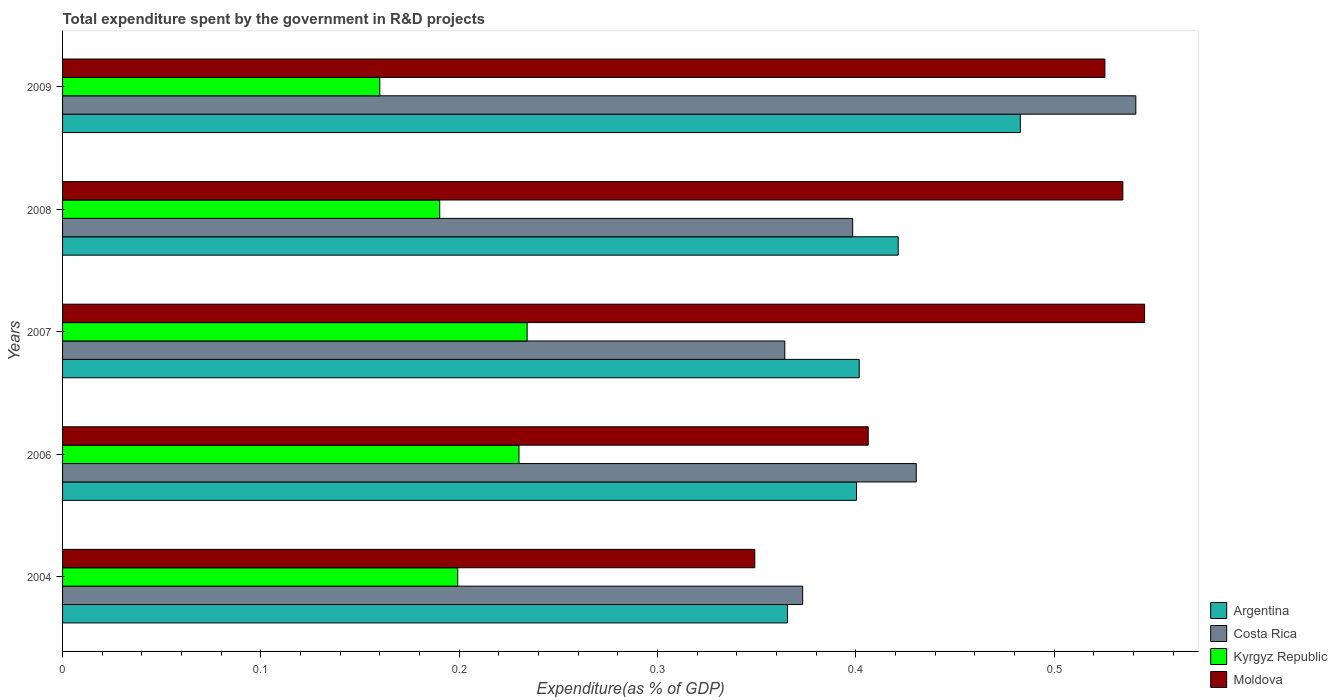How many different coloured bars are there?
Offer a very short reply. 4. How many groups of bars are there?
Ensure brevity in your answer.  5. Are the number of bars per tick equal to the number of legend labels?
Your answer should be very brief. Yes. How many bars are there on the 1st tick from the top?
Offer a terse response. 4. What is the label of the 3rd group of bars from the top?
Your answer should be compact. 2007. What is the total expenditure spent by the government in R&D projects in Costa Rica in 2009?
Make the answer very short. 0.54. Across all years, what is the maximum total expenditure spent by the government in R&D projects in Moldova?
Offer a terse response. 0.55. Across all years, what is the minimum total expenditure spent by the government in R&D projects in Kyrgyz Republic?
Give a very brief answer. 0.16. What is the total total expenditure spent by the government in R&D projects in Moldova in the graph?
Provide a short and direct response. 2.36. What is the difference between the total expenditure spent by the government in R&D projects in Kyrgyz Republic in 2006 and that in 2008?
Make the answer very short. 0.04. What is the difference between the total expenditure spent by the government in R&D projects in Costa Rica in 2004 and the total expenditure spent by the government in R&D projects in Kyrgyz Republic in 2007?
Your answer should be compact. 0.14. What is the average total expenditure spent by the government in R&D projects in Costa Rica per year?
Your answer should be very brief. 0.42. In the year 2009, what is the difference between the total expenditure spent by the government in R&D projects in Moldova and total expenditure spent by the government in R&D projects in Costa Rica?
Offer a very short reply. -0.02. What is the ratio of the total expenditure spent by the government in R&D projects in Argentina in 2007 to that in 2009?
Provide a short and direct response. 0.83. Is the total expenditure spent by the government in R&D projects in Costa Rica in 2006 less than that in 2007?
Offer a terse response. No. What is the difference between the highest and the second highest total expenditure spent by the government in R&D projects in Kyrgyz Republic?
Provide a short and direct response. 0. What is the difference between the highest and the lowest total expenditure spent by the government in R&D projects in Costa Rica?
Give a very brief answer. 0.18. In how many years, is the total expenditure spent by the government in R&D projects in Costa Rica greater than the average total expenditure spent by the government in R&D projects in Costa Rica taken over all years?
Your response must be concise. 2. Is the sum of the total expenditure spent by the government in R&D projects in Moldova in 2007 and 2008 greater than the maximum total expenditure spent by the government in R&D projects in Argentina across all years?
Provide a succinct answer. Yes. Is it the case that in every year, the sum of the total expenditure spent by the government in R&D projects in Moldova and total expenditure spent by the government in R&D projects in Argentina is greater than the sum of total expenditure spent by the government in R&D projects in Kyrgyz Republic and total expenditure spent by the government in R&D projects in Costa Rica?
Ensure brevity in your answer.  No. What does the 3rd bar from the top in 2004 represents?
Offer a terse response. Costa Rica. Is it the case that in every year, the sum of the total expenditure spent by the government in R&D projects in Moldova and total expenditure spent by the government in R&D projects in Argentina is greater than the total expenditure spent by the government in R&D projects in Kyrgyz Republic?
Ensure brevity in your answer.  Yes. How many bars are there?
Provide a succinct answer. 20. How many years are there in the graph?
Give a very brief answer. 5. What is the difference between two consecutive major ticks on the X-axis?
Provide a succinct answer. 0.1. Does the graph contain any zero values?
Keep it short and to the point. No. Does the graph contain grids?
Provide a succinct answer. No. Where does the legend appear in the graph?
Make the answer very short. Bottom right. How many legend labels are there?
Ensure brevity in your answer.  4. What is the title of the graph?
Provide a short and direct response. Total expenditure spent by the government in R&D projects. What is the label or title of the X-axis?
Give a very brief answer. Expenditure(as % of GDP). What is the Expenditure(as % of GDP) in Argentina in 2004?
Offer a very short reply. 0.37. What is the Expenditure(as % of GDP) in Costa Rica in 2004?
Your response must be concise. 0.37. What is the Expenditure(as % of GDP) in Kyrgyz Republic in 2004?
Give a very brief answer. 0.2. What is the Expenditure(as % of GDP) of Moldova in 2004?
Provide a succinct answer. 0.35. What is the Expenditure(as % of GDP) of Argentina in 2006?
Your response must be concise. 0.4. What is the Expenditure(as % of GDP) of Costa Rica in 2006?
Offer a very short reply. 0.43. What is the Expenditure(as % of GDP) in Kyrgyz Republic in 2006?
Your answer should be compact. 0.23. What is the Expenditure(as % of GDP) in Moldova in 2006?
Give a very brief answer. 0.41. What is the Expenditure(as % of GDP) of Argentina in 2007?
Offer a very short reply. 0.4. What is the Expenditure(as % of GDP) of Costa Rica in 2007?
Ensure brevity in your answer.  0.36. What is the Expenditure(as % of GDP) in Kyrgyz Republic in 2007?
Give a very brief answer. 0.23. What is the Expenditure(as % of GDP) in Moldova in 2007?
Give a very brief answer. 0.55. What is the Expenditure(as % of GDP) in Argentina in 2008?
Make the answer very short. 0.42. What is the Expenditure(as % of GDP) of Costa Rica in 2008?
Keep it short and to the point. 0.4. What is the Expenditure(as % of GDP) of Kyrgyz Republic in 2008?
Give a very brief answer. 0.19. What is the Expenditure(as % of GDP) of Moldova in 2008?
Make the answer very short. 0.53. What is the Expenditure(as % of GDP) in Argentina in 2009?
Provide a succinct answer. 0.48. What is the Expenditure(as % of GDP) of Costa Rica in 2009?
Offer a very short reply. 0.54. What is the Expenditure(as % of GDP) of Kyrgyz Republic in 2009?
Keep it short and to the point. 0.16. What is the Expenditure(as % of GDP) of Moldova in 2009?
Your answer should be very brief. 0.53. Across all years, what is the maximum Expenditure(as % of GDP) in Argentina?
Give a very brief answer. 0.48. Across all years, what is the maximum Expenditure(as % of GDP) in Costa Rica?
Offer a very short reply. 0.54. Across all years, what is the maximum Expenditure(as % of GDP) of Kyrgyz Republic?
Your answer should be compact. 0.23. Across all years, what is the maximum Expenditure(as % of GDP) in Moldova?
Your answer should be compact. 0.55. Across all years, what is the minimum Expenditure(as % of GDP) in Argentina?
Offer a terse response. 0.37. Across all years, what is the minimum Expenditure(as % of GDP) of Costa Rica?
Make the answer very short. 0.36. Across all years, what is the minimum Expenditure(as % of GDP) in Kyrgyz Republic?
Provide a succinct answer. 0.16. Across all years, what is the minimum Expenditure(as % of GDP) in Moldova?
Keep it short and to the point. 0.35. What is the total Expenditure(as % of GDP) in Argentina in the graph?
Make the answer very short. 2.07. What is the total Expenditure(as % of GDP) of Costa Rica in the graph?
Your answer should be very brief. 2.11. What is the total Expenditure(as % of GDP) of Kyrgyz Republic in the graph?
Your answer should be very brief. 1.01. What is the total Expenditure(as % of GDP) of Moldova in the graph?
Provide a short and direct response. 2.36. What is the difference between the Expenditure(as % of GDP) in Argentina in 2004 and that in 2006?
Your answer should be compact. -0.03. What is the difference between the Expenditure(as % of GDP) of Costa Rica in 2004 and that in 2006?
Offer a terse response. -0.06. What is the difference between the Expenditure(as % of GDP) of Kyrgyz Republic in 2004 and that in 2006?
Keep it short and to the point. -0.03. What is the difference between the Expenditure(as % of GDP) in Moldova in 2004 and that in 2006?
Your answer should be very brief. -0.06. What is the difference between the Expenditure(as % of GDP) in Argentina in 2004 and that in 2007?
Offer a very short reply. -0.04. What is the difference between the Expenditure(as % of GDP) of Costa Rica in 2004 and that in 2007?
Your answer should be very brief. 0.01. What is the difference between the Expenditure(as % of GDP) in Kyrgyz Republic in 2004 and that in 2007?
Your answer should be compact. -0.04. What is the difference between the Expenditure(as % of GDP) of Moldova in 2004 and that in 2007?
Offer a terse response. -0.2. What is the difference between the Expenditure(as % of GDP) in Argentina in 2004 and that in 2008?
Your answer should be compact. -0.06. What is the difference between the Expenditure(as % of GDP) in Costa Rica in 2004 and that in 2008?
Provide a short and direct response. -0.03. What is the difference between the Expenditure(as % of GDP) in Kyrgyz Republic in 2004 and that in 2008?
Make the answer very short. 0.01. What is the difference between the Expenditure(as % of GDP) in Moldova in 2004 and that in 2008?
Your response must be concise. -0.19. What is the difference between the Expenditure(as % of GDP) in Argentina in 2004 and that in 2009?
Your answer should be very brief. -0.12. What is the difference between the Expenditure(as % of GDP) in Costa Rica in 2004 and that in 2009?
Your answer should be very brief. -0.17. What is the difference between the Expenditure(as % of GDP) of Kyrgyz Republic in 2004 and that in 2009?
Offer a terse response. 0.04. What is the difference between the Expenditure(as % of GDP) in Moldova in 2004 and that in 2009?
Your answer should be very brief. -0.18. What is the difference between the Expenditure(as % of GDP) in Argentina in 2006 and that in 2007?
Offer a terse response. -0. What is the difference between the Expenditure(as % of GDP) of Costa Rica in 2006 and that in 2007?
Keep it short and to the point. 0.07. What is the difference between the Expenditure(as % of GDP) in Kyrgyz Republic in 2006 and that in 2007?
Offer a terse response. -0. What is the difference between the Expenditure(as % of GDP) in Moldova in 2006 and that in 2007?
Your answer should be very brief. -0.14. What is the difference between the Expenditure(as % of GDP) of Argentina in 2006 and that in 2008?
Ensure brevity in your answer.  -0.02. What is the difference between the Expenditure(as % of GDP) of Costa Rica in 2006 and that in 2008?
Make the answer very short. 0.03. What is the difference between the Expenditure(as % of GDP) of Kyrgyz Republic in 2006 and that in 2008?
Ensure brevity in your answer.  0.04. What is the difference between the Expenditure(as % of GDP) of Moldova in 2006 and that in 2008?
Keep it short and to the point. -0.13. What is the difference between the Expenditure(as % of GDP) of Argentina in 2006 and that in 2009?
Your response must be concise. -0.08. What is the difference between the Expenditure(as % of GDP) in Costa Rica in 2006 and that in 2009?
Give a very brief answer. -0.11. What is the difference between the Expenditure(as % of GDP) in Kyrgyz Republic in 2006 and that in 2009?
Your answer should be very brief. 0.07. What is the difference between the Expenditure(as % of GDP) of Moldova in 2006 and that in 2009?
Ensure brevity in your answer.  -0.12. What is the difference between the Expenditure(as % of GDP) of Argentina in 2007 and that in 2008?
Keep it short and to the point. -0.02. What is the difference between the Expenditure(as % of GDP) in Costa Rica in 2007 and that in 2008?
Give a very brief answer. -0.03. What is the difference between the Expenditure(as % of GDP) of Kyrgyz Republic in 2007 and that in 2008?
Keep it short and to the point. 0.04. What is the difference between the Expenditure(as % of GDP) of Moldova in 2007 and that in 2008?
Give a very brief answer. 0.01. What is the difference between the Expenditure(as % of GDP) in Argentina in 2007 and that in 2009?
Ensure brevity in your answer.  -0.08. What is the difference between the Expenditure(as % of GDP) of Costa Rica in 2007 and that in 2009?
Your response must be concise. -0.18. What is the difference between the Expenditure(as % of GDP) of Kyrgyz Republic in 2007 and that in 2009?
Keep it short and to the point. 0.07. What is the difference between the Expenditure(as % of GDP) in Moldova in 2007 and that in 2009?
Keep it short and to the point. 0.02. What is the difference between the Expenditure(as % of GDP) of Argentina in 2008 and that in 2009?
Give a very brief answer. -0.06. What is the difference between the Expenditure(as % of GDP) in Costa Rica in 2008 and that in 2009?
Provide a short and direct response. -0.14. What is the difference between the Expenditure(as % of GDP) in Kyrgyz Republic in 2008 and that in 2009?
Offer a terse response. 0.03. What is the difference between the Expenditure(as % of GDP) of Moldova in 2008 and that in 2009?
Provide a short and direct response. 0.01. What is the difference between the Expenditure(as % of GDP) in Argentina in 2004 and the Expenditure(as % of GDP) in Costa Rica in 2006?
Provide a succinct answer. -0.06. What is the difference between the Expenditure(as % of GDP) of Argentina in 2004 and the Expenditure(as % of GDP) of Kyrgyz Republic in 2006?
Your response must be concise. 0.14. What is the difference between the Expenditure(as % of GDP) in Argentina in 2004 and the Expenditure(as % of GDP) in Moldova in 2006?
Provide a short and direct response. -0.04. What is the difference between the Expenditure(as % of GDP) in Costa Rica in 2004 and the Expenditure(as % of GDP) in Kyrgyz Republic in 2006?
Your answer should be compact. 0.14. What is the difference between the Expenditure(as % of GDP) in Costa Rica in 2004 and the Expenditure(as % of GDP) in Moldova in 2006?
Make the answer very short. -0.03. What is the difference between the Expenditure(as % of GDP) of Kyrgyz Republic in 2004 and the Expenditure(as % of GDP) of Moldova in 2006?
Offer a very short reply. -0.21. What is the difference between the Expenditure(as % of GDP) of Argentina in 2004 and the Expenditure(as % of GDP) of Costa Rica in 2007?
Give a very brief answer. 0. What is the difference between the Expenditure(as % of GDP) in Argentina in 2004 and the Expenditure(as % of GDP) in Kyrgyz Republic in 2007?
Make the answer very short. 0.13. What is the difference between the Expenditure(as % of GDP) in Argentina in 2004 and the Expenditure(as % of GDP) in Moldova in 2007?
Offer a terse response. -0.18. What is the difference between the Expenditure(as % of GDP) in Costa Rica in 2004 and the Expenditure(as % of GDP) in Kyrgyz Republic in 2007?
Give a very brief answer. 0.14. What is the difference between the Expenditure(as % of GDP) of Costa Rica in 2004 and the Expenditure(as % of GDP) of Moldova in 2007?
Keep it short and to the point. -0.17. What is the difference between the Expenditure(as % of GDP) of Kyrgyz Republic in 2004 and the Expenditure(as % of GDP) of Moldova in 2007?
Provide a short and direct response. -0.35. What is the difference between the Expenditure(as % of GDP) in Argentina in 2004 and the Expenditure(as % of GDP) in Costa Rica in 2008?
Ensure brevity in your answer.  -0.03. What is the difference between the Expenditure(as % of GDP) of Argentina in 2004 and the Expenditure(as % of GDP) of Kyrgyz Republic in 2008?
Make the answer very short. 0.18. What is the difference between the Expenditure(as % of GDP) in Argentina in 2004 and the Expenditure(as % of GDP) in Moldova in 2008?
Make the answer very short. -0.17. What is the difference between the Expenditure(as % of GDP) of Costa Rica in 2004 and the Expenditure(as % of GDP) of Kyrgyz Republic in 2008?
Provide a short and direct response. 0.18. What is the difference between the Expenditure(as % of GDP) in Costa Rica in 2004 and the Expenditure(as % of GDP) in Moldova in 2008?
Your answer should be compact. -0.16. What is the difference between the Expenditure(as % of GDP) in Kyrgyz Republic in 2004 and the Expenditure(as % of GDP) in Moldova in 2008?
Offer a terse response. -0.34. What is the difference between the Expenditure(as % of GDP) in Argentina in 2004 and the Expenditure(as % of GDP) in Costa Rica in 2009?
Ensure brevity in your answer.  -0.18. What is the difference between the Expenditure(as % of GDP) in Argentina in 2004 and the Expenditure(as % of GDP) in Kyrgyz Republic in 2009?
Keep it short and to the point. 0.21. What is the difference between the Expenditure(as % of GDP) in Argentina in 2004 and the Expenditure(as % of GDP) in Moldova in 2009?
Keep it short and to the point. -0.16. What is the difference between the Expenditure(as % of GDP) in Costa Rica in 2004 and the Expenditure(as % of GDP) in Kyrgyz Republic in 2009?
Ensure brevity in your answer.  0.21. What is the difference between the Expenditure(as % of GDP) of Costa Rica in 2004 and the Expenditure(as % of GDP) of Moldova in 2009?
Make the answer very short. -0.15. What is the difference between the Expenditure(as % of GDP) of Kyrgyz Republic in 2004 and the Expenditure(as % of GDP) of Moldova in 2009?
Offer a very short reply. -0.33. What is the difference between the Expenditure(as % of GDP) of Argentina in 2006 and the Expenditure(as % of GDP) of Costa Rica in 2007?
Give a very brief answer. 0.04. What is the difference between the Expenditure(as % of GDP) of Argentina in 2006 and the Expenditure(as % of GDP) of Kyrgyz Republic in 2007?
Make the answer very short. 0.17. What is the difference between the Expenditure(as % of GDP) in Argentina in 2006 and the Expenditure(as % of GDP) in Moldova in 2007?
Offer a terse response. -0.15. What is the difference between the Expenditure(as % of GDP) of Costa Rica in 2006 and the Expenditure(as % of GDP) of Kyrgyz Republic in 2007?
Keep it short and to the point. 0.2. What is the difference between the Expenditure(as % of GDP) in Costa Rica in 2006 and the Expenditure(as % of GDP) in Moldova in 2007?
Provide a short and direct response. -0.12. What is the difference between the Expenditure(as % of GDP) of Kyrgyz Republic in 2006 and the Expenditure(as % of GDP) of Moldova in 2007?
Ensure brevity in your answer.  -0.32. What is the difference between the Expenditure(as % of GDP) in Argentina in 2006 and the Expenditure(as % of GDP) in Costa Rica in 2008?
Ensure brevity in your answer.  0. What is the difference between the Expenditure(as % of GDP) in Argentina in 2006 and the Expenditure(as % of GDP) in Kyrgyz Republic in 2008?
Keep it short and to the point. 0.21. What is the difference between the Expenditure(as % of GDP) of Argentina in 2006 and the Expenditure(as % of GDP) of Moldova in 2008?
Provide a succinct answer. -0.13. What is the difference between the Expenditure(as % of GDP) of Costa Rica in 2006 and the Expenditure(as % of GDP) of Kyrgyz Republic in 2008?
Provide a succinct answer. 0.24. What is the difference between the Expenditure(as % of GDP) of Costa Rica in 2006 and the Expenditure(as % of GDP) of Moldova in 2008?
Make the answer very short. -0.1. What is the difference between the Expenditure(as % of GDP) in Kyrgyz Republic in 2006 and the Expenditure(as % of GDP) in Moldova in 2008?
Make the answer very short. -0.3. What is the difference between the Expenditure(as % of GDP) of Argentina in 2006 and the Expenditure(as % of GDP) of Costa Rica in 2009?
Ensure brevity in your answer.  -0.14. What is the difference between the Expenditure(as % of GDP) of Argentina in 2006 and the Expenditure(as % of GDP) of Kyrgyz Republic in 2009?
Give a very brief answer. 0.24. What is the difference between the Expenditure(as % of GDP) in Argentina in 2006 and the Expenditure(as % of GDP) in Moldova in 2009?
Make the answer very short. -0.13. What is the difference between the Expenditure(as % of GDP) of Costa Rica in 2006 and the Expenditure(as % of GDP) of Kyrgyz Republic in 2009?
Offer a terse response. 0.27. What is the difference between the Expenditure(as % of GDP) of Costa Rica in 2006 and the Expenditure(as % of GDP) of Moldova in 2009?
Make the answer very short. -0.1. What is the difference between the Expenditure(as % of GDP) in Kyrgyz Republic in 2006 and the Expenditure(as % of GDP) in Moldova in 2009?
Keep it short and to the point. -0.3. What is the difference between the Expenditure(as % of GDP) in Argentina in 2007 and the Expenditure(as % of GDP) in Costa Rica in 2008?
Give a very brief answer. 0. What is the difference between the Expenditure(as % of GDP) in Argentina in 2007 and the Expenditure(as % of GDP) in Kyrgyz Republic in 2008?
Provide a succinct answer. 0.21. What is the difference between the Expenditure(as % of GDP) in Argentina in 2007 and the Expenditure(as % of GDP) in Moldova in 2008?
Offer a terse response. -0.13. What is the difference between the Expenditure(as % of GDP) in Costa Rica in 2007 and the Expenditure(as % of GDP) in Kyrgyz Republic in 2008?
Ensure brevity in your answer.  0.17. What is the difference between the Expenditure(as % of GDP) in Costa Rica in 2007 and the Expenditure(as % of GDP) in Moldova in 2008?
Make the answer very short. -0.17. What is the difference between the Expenditure(as % of GDP) of Kyrgyz Republic in 2007 and the Expenditure(as % of GDP) of Moldova in 2008?
Offer a very short reply. -0.3. What is the difference between the Expenditure(as % of GDP) in Argentina in 2007 and the Expenditure(as % of GDP) in Costa Rica in 2009?
Offer a terse response. -0.14. What is the difference between the Expenditure(as % of GDP) of Argentina in 2007 and the Expenditure(as % of GDP) of Kyrgyz Republic in 2009?
Provide a succinct answer. 0.24. What is the difference between the Expenditure(as % of GDP) of Argentina in 2007 and the Expenditure(as % of GDP) of Moldova in 2009?
Your response must be concise. -0.12. What is the difference between the Expenditure(as % of GDP) in Costa Rica in 2007 and the Expenditure(as % of GDP) in Kyrgyz Republic in 2009?
Your answer should be compact. 0.2. What is the difference between the Expenditure(as % of GDP) in Costa Rica in 2007 and the Expenditure(as % of GDP) in Moldova in 2009?
Provide a succinct answer. -0.16. What is the difference between the Expenditure(as % of GDP) of Kyrgyz Republic in 2007 and the Expenditure(as % of GDP) of Moldova in 2009?
Provide a succinct answer. -0.29. What is the difference between the Expenditure(as % of GDP) in Argentina in 2008 and the Expenditure(as % of GDP) in Costa Rica in 2009?
Make the answer very short. -0.12. What is the difference between the Expenditure(as % of GDP) in Argentina in 2008 and the Expenditure(as % of GDP) in Kyrgyz Republic in 2009?
Offer a very short reply. 0.26. What is the difference between the Expenditure(as % of GDP) of Argentina in 2008 and the Expenditure(as % of GDP) of Moldova in 2009?
Ensure brevity in your answer.  -0.1. What is the difference between the Expenditure(as % of GDP) in Costa Rica in 2008 and the Expenditure(as % of GDP) in Kyrgyz Republic in 2009?
Your answer should be very brief. 0.24. What is the difference between the Expenditure(as % of GDP) in Costa Rica in 2008 and the Expenditure(as % of GDP) in Moldova in 2009?
Offer a very short reply. -0.13. What is the difference between the Expenditure(as % of GDP) in Kyrgyz Republic in 2008 and the Expenditure(as % of GDP) in Moldova in 2009?
Your response must be concise. -0.34. What is the average Expenditure(as % of GDP) of Argentina per year?
Your answer should be compact. 0.41. What is the average Expenditure(as % of GDP) of Costa Rica per year?
Ensure brevity in your answer.  0.42. What is the average Expenditure(as % of GDP) in Kyrgyz Republic per year?
Provide a short and direct response. 0.2. What is the average Expenditure(as % of GDP) of Moldova per year?
Offer a very short reply. 0.47. In the year 2004, what is the difference between the Expenditure(as % of GDP) in Argentina and Expenditure(as % of GDP) in Costa Rica?
Your answer should be very brief. -0.01. In the year 2004, what is the difference between the Expenditure(as % of GDP) in Argentina and Expenditure(as % of GDP) in Kyrgyz Republic?
Offer a very short reply. 0.17. In the year 2004, what is the difference between the Expenditure(as % of GDP) in Argentina and Expenditure(as % of GDP) in Moldova?
Your answer should be very brief. 0.02. In the year 2004, what is the difference between the Expenditure(as % of GDP) in Costa Rica and Expenditure(as % of GDP) in Kyrgyz Republic?
Provide a short and direct response. 0.17. In the year 2004, what is the difference between the Expenditure(as % of GDP) of Costa Rica and Expenditure(as % of GDP) of Moldova?
Offer a very short reply. 0.02. In the year 2004, what is the difference between the Expenditure(as % of GDP) in Kyrgyz Republic and Expenditure(as % of GDP) in Moldova?
Provide a succinct answer. -0.15. In the year 2006, what is the difference between the Expenditure(as % of GDP) in Argentina and Expenditure(as % of GDP) in Costa Rica?
Ensure brevity in your answer.  -0.03. In the year 2006, what is the difference between the Expenditure(as % of GDP) in Argentina and Expenditure(as % of GDP) in Kyrgyz Republic?
Provide a succinct answer. 0.17. In the year 2006, what is the difference between the Expenditure(as % of GDP) in Argentina and Expenditure(as % of GDP) in Moldova?
Give a very brief answer. -0.01. In the year 2006, what is the difference between the Expenditure(as % of GDP) in Costa Rica and Expenditure(as % of GDP) in Kyrgyz Republic?
Provide a succinct answer. 0.2. In the year 2006, what is the difference between the Expenditure(as % of GDP) in Costa Rica and Expenditure(as % of GDP) in Moldova?
Ensure brevity in your answer.  0.02. In the year 2006, what is the difference between the Expenditure(as % of GDP) in Kyrgyz Republic and Expenditure(as % of GDP) in Moldova?
Offer a very short reply. -0.18. In the year 2007, what is the difference between the Expenditure(as % of GDP) in Argentina and Expenditure(as % of GDP) in Costa Rica?
Offer a terse response. 0.04. In the year 2007, what is the difference between the Expenditure(as % of GDP) of Argentina and Expenditure(as % of GDP) of Kyrgyz Republic?
Your response must be concise. 0.17. In the year 2007, what is the difference between the Expenditure(as % of GDP) in Argentina and Expenditure(as % of GDP) in Moldova?
Your answer should be very brief. -0.14. In the year 2007, what is the difference between the Expenditure(as % of GDP) of Costa Rica and Expenditure(as % of GDP) of Kyrgyz Republic?
Offer a very short reply. 0.13. In the year 2007, what is the difference between the Expenditure(as % of GDP) in Costa Rica and Expenditure(as % of GDP) in Moldova?
Offer a terse response. -0.18. In the year 2007, what is the difference between the Expenditure(as % of GDP) of Kyrgyz Republic and Expenditure(as % of GDP) of Moldova?
Ensure brevity in your answer.  -0.31. In the year 2008, what is the difference between the Expenditure(as % of GDP) in Argentina and Expenditure(as % of GDP) in Costa Rica?
Make the answer very short. 0.02. In the year 2008, what is the difference between the Expenditure(as % of GDP) of Argentina and Expenditure(as % of GDP) of Kyrgyz Republic?
Your answer should be very brief. 0.23. In the year 2008, what is the difference between the Expenditure(as % of GDP) in Argentina and Expenditure(as % of GDP) in Moldova?
Offer a very short reply. -0.11. In the year 2008, what is the difference between the Expenditure(as % of GDP) of Costa Rica and Expenditure(as % of GDP) of Kyrgyz Republic?
Provide a short and direct response. 0.21. In the year 2008, what is the difference between the Expenditure(as % of GDP) of Costa Rica and Expenditure(as % of GDP) of Moldova?
Your response must be concise. -0.14. In the year 2008, what is the difference between the Expenditure(as % of GDP) of Kyrgyz Republic and Expenditure(as % of GDP) of Moldova?
Offer a terse response. -0.34. In the year 2009, what is the difference between the Expenditure(as % of GDP) in Argentina and Expenditure(as % of GDP) in Costa Rica?
Offer a very short reply. -0.06. In the year 2009, what is the difference between the Expenditure(as % of GDP) in Argentina and Expenditure(as % of GDP) in Kyrgyz Republic?
Your response must be concise. 0.32. In the year 2009, what is the difference between the Expenditure(as % of GDP) of Argentina and Expenditure(as % of GDP) of Moldova?
Provide a short and direct response. -0.04. In the year 2009, what is the difference between the Expenditure(as % of GDP) in Costa Rica and Expenditure(as % of GDP) in Kyrgyz Republic?
Your answer should be very brief. 0.38. In the year 2009, what is the difference between the Expenditure(as % of GDP) in Costa Rica and Expenditure(as % of GDP) in Moldova?
Keep it short and to the point. 0.02. In the year 2009, what is the difference between the Expenditure(as % of GDP) of Kyrgyz Republic and Expenditure(as % of GDP) of Moldova?
Keep it short and to the point. -0.37. What is the ratio of the Expenditure(as % of GDP) of Argentina in 2004 to that in 2006?
Offer a terse response. 0.91. What is the ratio of the Expenditure(as % of GDP) of Costa Rica in 2004 to that in 2006?
Provide a short and direct response. 0.87. What is the ratio of the Expenditure(as % of GDP) of Kyrgyz Republic in 2004 to that in 2006?
Your response must be concise. 0.87. What is the ratio of the Expenditure(as % of GDP) in Moldova in 2004 to that in 2006?
Give a very brief answer. 0.86. What is the ratio of the Expenditure(as % of GDP) in Argentina in 2004 to that in 2007?
Your response must be concise. 0.91. What is the ratio of the Expenditure(as % of GDP) of Costa Rica in 2004 to that in 2007?
Ensure brevity in your answer.  1.02. What is the ratio of the Expenditure(as % of GDP) in Kyrgyz Republic in 2004 to that in 2007?
Give a very brief answer. 0.85. What is the ratio of the Expenditure(as % of GDP) of Moldova in 2004 to that in 2007?
Provide a succinct answer. 0.64. What is the ratio of the Expenditure(as % of GDP) in Argentina in 2004 to that in 2008?
Keep it short and to the point. 0.87. What is the ratio of the Expenditure(as % of GDP) in Costa Rica in 2004 to that in 2008?
Your answer should be very brief. 0.94. What is the ratio of the Expenditure(as % of GDP) of Kyrgyz Republic in 2004 to that in 2008?
Give a very brief answer. 1.05. What is the ratio of the Expenditure(as % of GDP) in Moldova in 2004 to that in 2008?
Provide a succinct answer. 0.65. What is the ratio of the Expenditure(as % of GDP) in Argentina in 2004 to that in 2009?
Offer a very short reply. 0.76. What is the ratio of the Expenditure(as % of GDP) of Costa Rica in 2004 to that in 2009?
Ensure brevity in your answer.  0.69. What is the ratio of the Expenditure(as % of GDP) in Kyrgyz Republic in 2004 to that in 2009?
Make the answer very short. 1.25. What is the ratio of the Expenditure(as % of GDP) of Moldova in 2004 to that in 2009?
Keep it short and to the point. 0.66. What is the ratio of the Expenditure(as % of GDP) in Argentina in 2006 to that in 2007?
Provide a succinct answer. 1. What is the ratio of the Expenditure(as % of GDP) in Costa Rica in 2006 to that in 2007?
Make the answer very short. 1.18. What is the ratio of the Expenditure(as % of GDP) of Kyrgyz Republic in 2006 to that in 2007?
Make the answer very short. 0.98. What is the ratio of the Expenditure(as % of GDP) of Moldova in 2006 to that in 2007?
Offer a terse response. 0.74. What is the ratio of the Expenditure(as % of GDP) of Argentina in 2006 to that in 2008?
Offer a terse response. 0.95. What is the ratio of the Expenditure(as % of GDP) in Costa Rica in 2006 to that in 2008?
Provide a succinct answer. 1.08. What is the ratio of the Expenditure(as % of GDP) of Kyrgyz Republic in 2006 to that in 2008?
Your answer should be very brief. 1.21. What is the ratio of the Expenditure(as % of GDP) in Moldova in 2006 to that in 2008?
Provide a succinct answer. 0.76. What is the ratio of the Expenditure(as % of GDP) in Argentina in 2006 to that in 2009?
Provide a short and direct response. 0.83. What is the ratio of the Expenditure(as % of GDP) of Costa Rica in 2006 to that in 2009?
Offer a terse response. 0.8. What is the ratio of the Expenditure(as % of GDP) in Kyrgyz Republic in 2006 to that in 2009?
Offer a terse response. 1.44. What is the ratio of the Expenditure(as % of GDP) in Moldova in 2006 to that in 2009?
Offer a very short reply. 0.77. What is the ratio of the Expenditure(as % of GDP) of Argentina in 2007 to that in 2008?
Offer a very short reply. 0.95. What is the ratio of the Expenditure(as % of GDP) in Costa Rica in 2007 to that in 2008?
Make the answer very short. 0.91. What is the ratio of the Expenditure(as % of GDP) in Kyrgyz Republic in 2007 to that in 2008?
Your answer should be compact. 1.23. What is the ratio of the Expenditure(as % of GDP) of Moldova in 2007 to that in 2008?
Your answer should be very brief. 1.02. What is the ratio of the Expenditure(as % of GDP) in Argentina in 2007 to that in 2009?
Make the answer very short. 0.83. What is the ratio of the Expenditure(as % of GDP) of Costa Rica in 2007 to that in 2009?
Offer a terse response. 0.67. What is the ratio of the Expenditure(as % of GDP) of Kyrgyz Republic in 2007 to that in 2009?
Make the answer very short. 1.46. What is the ratio of the Expenditure(as % of GDP) of Moldova in 2007 to that in 2009?
Your response must be concise. 1.04. What is the ratio of the Expenditure(as % of GDP) of Argentina in 2008 to that in 2009?
Offer a terse response. 0.87. What is the ratio of the Expenditure(as % of GDP) in Costa Rica in 2008 to that in 2009?
Keep it short and to the point. 0.74. What is the ratio of the Expenditure(as % of GDP) in Kyrgyz Republic in 2008 to that in 2009?
Offer a very short reply. 1.19. What is the ratio of the Expenditure(as % of GDP) of Moldova in 2008 to that in 2009?
Your answer should be very brief. 1.02. What is the difference between the highest and the second highest Expenditure(as % of GDP) of Argentina?
Offer a terse response. 0.06. What is the difference between the highest and the second highest Expenditure(as % of GDP) in Costa Rica?
Provide a short and direct response. 0.11. What is the difference between the highest and the second highest Expenditure(as % of GDP) of Kyrgyz Republic?
Your answer should be compact. 0. What is the difference between the highest and the second highest Expenditure(as % of GDP) of Moldova?
Ensure brevity in your answer.  0.01. What is the difference between the highest and the lowest Expenditure(as % of GDP) of Argentina?
Offer a very short reply. 0.12. What is the difference between the highest and the lowest Expenditure(as % of GDP) in Costa Rica?
Provide a succinct answer. 0.18. What is the difference between the highest and the lowest Expenditure(as % of GDP) in Kyrgyz Republic?
Provide a succinct answer. 0.07. What is the difference between the highest and the lowest Expenditure(as % of GDP) of Moldova?
Give a very brief answer. 0.2. 